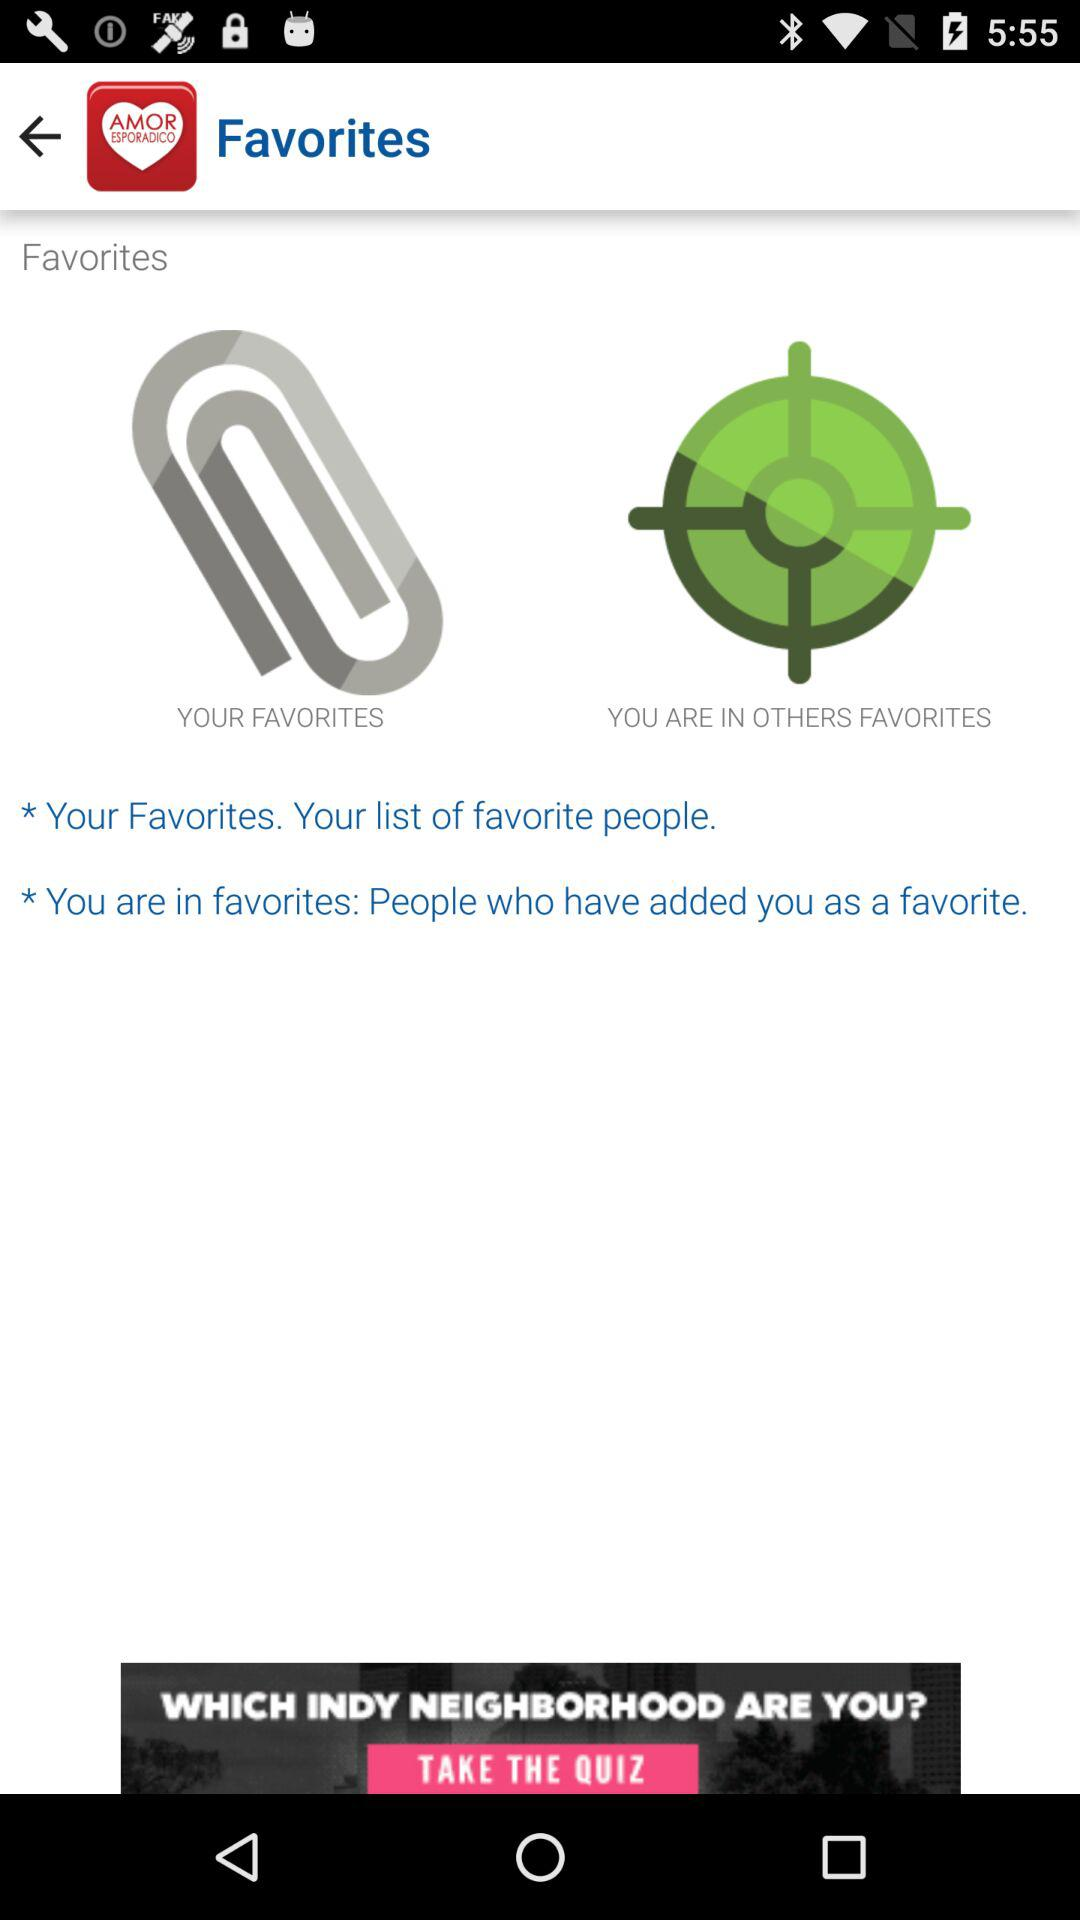What is the application name? The application name is "AmorEsporadico". 